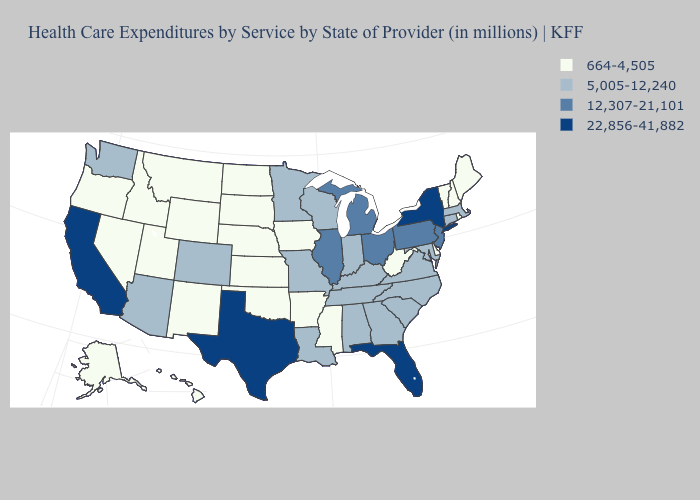Among the states that border Arizona , which have the highest value?
Quick response, please. California. Name the states that have a value in the range 664-4,505?
Give a very brief answer. Alaska, Arkansas, Delaware, Hawaii, Idaho, Iowa, Kansas, Maine, Mississippi, Montana, Nebraska, Nevada, New Hampshire, New Mexico, North Dakota, Oklahoma, Oregon, Rhode Island, South Dakota, Utah, Vermont, West Virginia, Wyoming. Name the states that have a value in the range 22,856-41,882?
Keep it brief. California, Florida, New York, Texas. Name the states that have a value in the range 664-4,505?
Quick response, please. Alaska, Arkansas, Delaware, Hawaii, Idaho, Iowa, Kansas, Maine, Mississippi, Montana, Nebraska, Nevada, New Hampshire, New Mexico, North Dakota, Oklahoma, Oregon, Rhode Island, South Dakota, Utah, Vermont, West Virginia, Wyoming. What is the value of Illinois?
Keep it brief. 12,307-21,101. What is the highest value in states that border West Virginia?
Quick response, please. 12,307-21,101. Name the states that have a value in the range 5,005-12,240?
Give a very brief answer. Alabama, Arizona, Colorado, Connecticut, Georgia, Indiana, Kentucky, Louisiana, Maryland, Massachusetts, Minnesota, Missouri, North Carolina, South Carolina, Tennessee, Virginia, Washington, Wisconsin. Name the states that have a value in the range 22,856-41,882?
Concise answer only. California, Florida, New York, Texas. What is the value of Rhode Island?
Give a very brief answer. 664-4,505. What is the value of Virginia?
Keep it brief. 5,005-12,240. Does California have the highest value in the West?
Be succinct. Yes. Name the states that have a value in the range 22,856-41,882?
Give a very brief answer. California, Florida, New York, Texas. Does Illinois have a lower value than Texas?
Keep it brief. Yes. What is the highest value in the MidWest ?
Quick response, please. 12,307-21,101. Which states have the lowest value in the MidWest?
Concise answer only. Iowa, Kansas, Nebraska, North Dakota, South Dakota. 